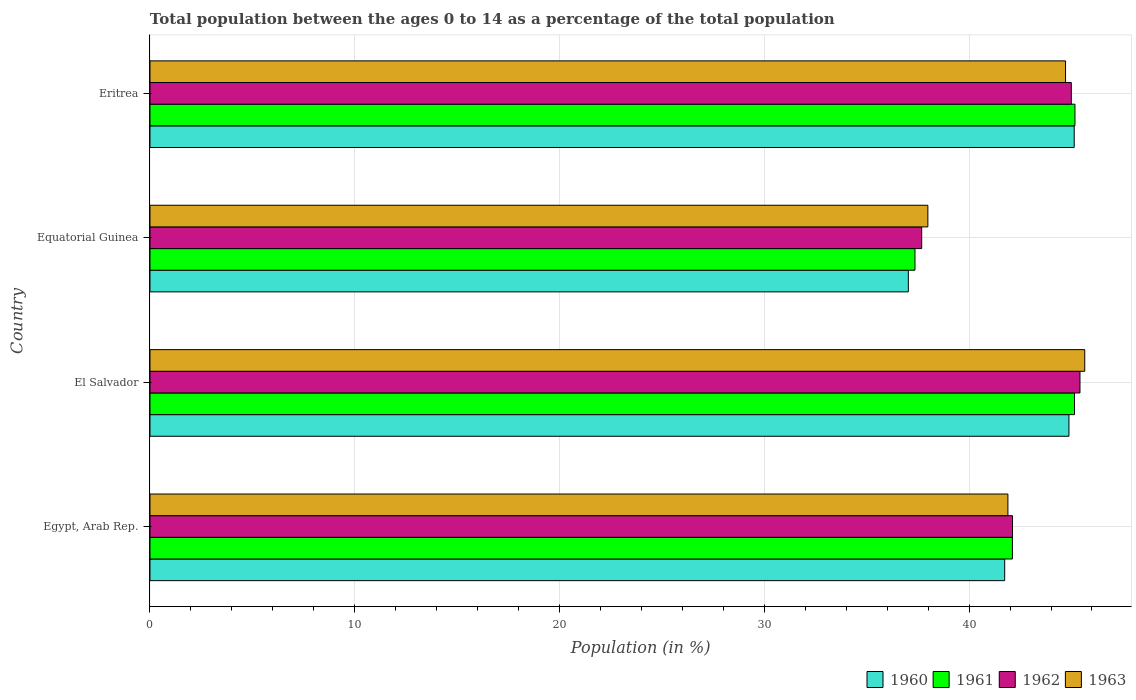Are the number of bars per tick equal to the number of legend labels?
Your response must be concise. Yes. Are the number of bars on each tick of the Y-axis equal?
Offer a terse response. Yes. What is the label of the 3rd group of bars from the top?
Your answer should be compact. El Salvador. What is the percentage of the population ages 0 to 14 in 1961 in Eritrea?
Give a very brief answer. 45.17. Across all countries, what is the maximum percentage of the population ages 0 to 14 in 1962?
Your answer should be very brief. 45.41. Across all countries, what is the minimum percentage of the population ages 0 to 14 in 1963?
Offer a terse response. 37.98. In which country was the percentage of the population ages 0 to 14 in 1961 maximum?
Your response must be concise. Eritrea. In which country was the percentage of the population ages 0 to 14 in 1963 minimum?
Provide a short and direct response. Equatorial Guinea. What is the total percentage of the population ages 0 to 14 in 1961 in the graph?
Your answer should be very brief. 169.78. What is the difference between the percentage of the population ages 0 to 14 in 1962 in Egypt, Arab Rep. and that in El Salvador?
Your answer should be compact. -3.29. What is the difference between the percentage of the population ages 0 to 14 in 1960 in Eritrea and the percentage of the population ages 0 to 14 in 1961 in El Salvador?
Your answer should be compact. -0.02. What is the average percentage of the population ages 0 to 14 in 1963 per country?
Ensure brevity in your answer.  42.56. What is the difference between the percentage of the population ages 0 to 14 in 1961 and percentage of the population ages 0 to 14 in 1962 in El Salvador?
Keep it short and to the point. -0.27. What is the ratio of the percentage of the population ages 0 to 14 in 1961 in Egypt, Arab Rep. to that in El Salvador?
Make the answer very short. 0.93. Is the percentage of the population ages 0 to 14 in 1960 in Equatorial Guinea less than that in Eritrea?
Give a very brief answer. Yes. Is the difference between the percentage of the population ages 0 to 14 in 1961 in Egypt, Arab Rep. and Eritrea greater than the difference between the percentage of the population ages 0 to 14 in 1962 in Egypt, Arab Rep. and Eritrea?
Offer a terse response. No. What is the difference between the highest and the second highest percentage of the population ages 0 to 14 in 1961?
Make the answer very short. 0.02. What is the difference between the highest and the lowest percentage of the population ages 0 to 14 in 1960?
Your answer should be compact. 8.1. In how many countries, is the percentage of the population ages 0 to 14 in 1963 greater than the average percentage of the population ages 0 to 14 in 1963 taken over all countries?
Provide a succinct answer. 2. What does the 4th bar from the bottom in Equatorial Guinea represents?
Offer a terse response. 1963. How many countries are there in the graph?
Your answer should be compact. 4. Where does the legend appear in the graph?
Make the answer very short. Bottom right. How many legend labels are there?
Your answer should be very brief. 4. What is the title of the graph?
Offer a very short reply. Total population between the ages 0 to 14 as a percentage of the total population. What is the Population (in %) of 1960 in Egypt, Arab Rep.?
Your response must be concise. 41.74. What is the Population (in %) of 1961 in Egypt, Arab Rep.?
Your answer should be very brief. 42.11. What is the Population (in %) in 1962 in Egypt, Arab Rep.?
Offer a terse response. 42.12. What is the Population (in %) in 1963 in Egypt, Arab Rep.?
Your response must be concise. 41.89. What is the Population (in %) of 1960 in El Salvador?
Your answer should be very brief. 44.87. What is the Population (in %) in 1961 in El Salvador?
Ensure brevity in your answer.  45.15. What is the Population (in %) of 1962 in El Salvador?
Make the answer very short. 45.41. What is the Population (in %) in 1963 in El Salvador?
Provide a short and direct response. 45.65. What is the Population (in %) in 1960 in Equatorial Guinea?
Your answer should be very brief. 37.03. What is the Population (in %) of 1961 in Equatorial Guinea?
Offer a very short reply. 37.36. What is the Population (in %) of 1962 in Equatorial Guinea?
Offer a terse response. 37.68. What is the Population (in %) of 1963 in Equatorial Guinea?
Offer a very short reply. 37.98. What is the Population (in %) in 1960 in Eritrea?
Provide a short and direct response. 45.13. What is the Population (in %) in 1961 in Eritrea?
Your response must be concise. 45.17. What is the Population (in %) of 1962 in Eritrea?
Ensure brevity in your answer.  44.99. What is the Population (in %) of 1963 in Eritrea?
Give a very brief answer. 44.71. Across all countries, what is the maximum Population (in %) of 1960?
Offer a terse response. 45.13. Across all countries, what is the maximum Population (in %) of 1961?
Ensure brevity in your answer.  45.17. Across all countries, what is the maximum Population (in %) of 1962?
Provide a short and direct response. 45.41. Across all countries, what is the maximum Population (in %) of 1963?
Ensure brevity in your answer.  45.65. Across all countries, what is the minimum Population (in %) in 1960?
Give a very brief answer. 37.03. Across all countries, what is the minimum Population (in %) of 1961?
Keep it short and to the point. 37.36. Across all countries, what is the minimum Population (in %) in 1962?
Offer a terse response. 37.68. Across all countries, what is the minimum Population (in %) of 1963?
Make the answer very short. 37.98. What is the total Population (in %) of 1960 in the graph?
Your answer should be very brief. 168.78. What is the total Population (in %) of 1961 in the graph?
Keep it short and to the point. 169.78. What is the total Population (in %) of 1962 in the graph?
Keep it short and to the point. 170.21. What is the total Population (in %) in 1963 in the graph?
Offer a very short reply. 170.23. What is the difference between the Population (in %) of 1960 in Egypt, Arab Rep. and that in El Salvador?
Your response must be concise. -3.14. What is the difference between the Population (in %) in 1961 in Egypt, Arab Rep. and that in El Salvador?
Keep it short and to the point. -3.03. What is the difference between the Population (in %) in 1962 in Egypt, Arab Rep. and that in El Salvador?
Offer a very short reply. -3.29. What is the difference between the Population (in %) in 1963 in Egypt, Arab Rep. and that in El Salvador?
Make the answer very short. -3.75. What is the difference between the Population (in %) of 1960 in Egypt, Arab Rep. and that in Equatorial Guinea?
Ensure brevity in your answer.  4.7. What is the difference between the Population (in %) of 1961 in Egypt, Arab Rep. and that in Equatorial Guinea?
Your answer should be compact. 4.76. What is the difference between the Population (in %) of 1962 in Egypt, Arab Rep. and that in Equatorial Guinea?
Your answer should be very brief. 4.43. What is the difference between the Population (in %) of 1963 in Egypt, Arab Rep. and that in Equatorial Guinea?
Give a very brief answer. 3.91. What is the difference between the Population (in %) of 1960 in Egypt, Arab Rep. and that in Eritrea?
Keep it short and to the point. -3.39. What is the difference between the Population (in %) in 1961 in Egypt, Arab Rep. and that in Eritrea?
Provide a succinct answer. -3.05. What is the difference between the Population (in %) of 1962 in Egypt, Arab Rep. and that in Eritrea?
Your response must be concise. -2.87. What is the difference between the Population (in %) in 1963 in Egypt, Arab Rep. and that in Eritrea?
Make the answer very short. -2.81. What is the difference between the Population (in %) of 1960 in El Salvador and that in Equatorial Guinea?
Your answer should be very brief. 7.84. What is the difference between the Population (in %) of 1961 in El Salvador and that in Equatorial Guinea?
Offer a very short reply. 7.79. What is the difference between the Population (in %) of 1962 in El Salvador and that in Equatorial Guinea?
Offer a terse response. 7.73. What is the difference between the Population (in %) of 1963 in El Salvador and that in Equatorial Guinea?
Your answer should be compact. 7.66. What is the difference between the Population (in %) in 1960 in El Salvador and that in Eritrea?
Your answer should be compact. -0.26. What is the difference between the Population (in %) in 1961 in El Salvador and that in Eritrea?
Ensure brevity in your answer.  -0.02. What is the difference between the Population (in %) of 1962 in El Salvador and that in Eritrea?
Your response must be concise. 0.42. What is the difference between the Population (in %) in 1963 in El Salvador and that in Eritrea?
Your response must be concise. 0.94. What is the difference between the Population (in %) in 1960 in Equatorial Guinea and that in Eritrea?
Make the answer very short. -8.1. What is the difference between the Population (in %) of 1961 in Equatorial Guinea and that in Eritrea?
Keep it short and to the point. -7.81. What is the difference between the Population (in %) of 1962 in Equatorial Guinea and that in Eritrea?
Keep it short and to the point. -7.31. What is the difference between the Population (in %) of 1963 in Equatorial Guinea and that in Eritrea?
Make the answer very short. -6.72. What is the difference between the Population (in %) of 1960 in Egypt, Arab Rep. and the Population (in %) of 1961 in El Salvador?
Your answer should be compact. -3.41. What is the difference between the Population (in %) in 1960 in Egypt, Arab Rep. and the Population (in %) in 1962 in El Salvador?
Make the answer very short. -3.68. What is the difference between the Population (in %) in 1960 in Egypt, Arab Rep. and the Population (in %) in 1963 in El Salvador?
Offer a very short reply. -3.91. What is the difference between the Population (in %) in 1961 in Egypt, Arab Rep. and the Population (in %) in 1962 in El Salvador?
Ensure brevity in your answer.  -3.3. What is the difference between the Population (in %) of 1961 in Egypt, Arab Rep. and the Population (in %) of 1963 in El Salvador?
Offer a very short reply. -3.53. What is the difference between the Population (in %) in 1962 in Egypt, Arab Rep. and the Population (in %) in 1963 in El Salvador?
Provide a succinct answer. -3.53. What is the difference between the Population (in %) in 1960 in Egypt, Arab Rep. and the Population (in %) in 1961 in Equatorial Guinea?
Keep it short and to the point. 4.38. What is the difference between the Population (in %) in 1960 in Egypt, Arab Rep. and the Population (in %) in 1962 in Equatorial Guinea?
Provide a succinct answer. 4.05. What is the difference between the Population (in %) in 1960 in Egypt, Arab Rep. and the Population (in %) in 1963 in Equatorial Guinea?
Offer a very short reply. 3.75. What is the difference between the Population (in %) in 1961 in Egypt, Arab Rep. and the Population (in %) in 1962 in Equatorial Guinea?
Ensure brevity in your answer.  4.43. What is the difference between the Population (in %) of 1961 in Egypt, Arab Rep. and the Population (in %) of 1963 in Equatorial Guinea?
Provide a succinct answer. 4.13. What is the difference between the Population (in %) in 1962 in Egypt, Arab Rep. and the Population (in %) in 1963 in Equatorial Guinea?
Make the answer very short. 4.13. What is the difference between the Population (in %) of 1960 in Egypt, Arab Rep. and the Population (in %) of 1961 in Eritrea?
Your answer should be very brief. -3.43. What is the difference between the Population (in %) in 1960 in Egypt, Arab Rep. and the Population (in %) in 1962 in Eritrea?
Your answer should be compact. -3.25. What is the difference between the Population (in %) of 1960 in Egypt, Arab Rep. and the Population (in %) of 1963 in Eritrea?
Your answer should be very brief. -2.97. What is the difference between the Population (in %) of 1961 in Egypt, Arab Rep. and the Population (in %) of 1962 in Eritrea?
Offer a very short reply. -2.88. What is the difference between the Population (in %) in 1961 in Egypt, Arab Rep. and the Population (in %) in 1963 in Eritrea?
Your response must be concise. -2.59. What is the difference between the Population (in %) in 1962 in Egypt, Arab Rep. and the Population (in %) in 1963 in Eritrea?
Keep it short and to the point. -2.59. What is the difference between the Population (in %) in 1960 in El Salvador and the Population (in %) in 1961 in Equatorial Guinea?
Give a very brief answer. 7.52. What is the difference between the Population (in %) of 1960 in El Salvador and the Population (in %) of 1962 in Equatorial Guinea?
Provide a short and direct response. 7.19. What is the difference between the Population (in %) of 1960 in El Salvador and the Population (in %) of 1963 in Equatorial Guinea?
Keep it short and to the point. 6.89. What is the difference between the Population (in %) in 1961 in El Salvador and the Population (in %) in 1962 in Equatorial Guinea?
Your answer should be compact. 7.46. What is the difference between the Population (in %) of 1961 in El Salvador and the Population (in %) of 1963 in Equatorial Guinea?
Offer a very short reply. 7.16. What is the difference between the Population (in %) of 1962 in El Salvador and the Population (in %) of 1963 in Equatorial Guinea?
Your answer should be very brief. 7.43. What is the difference between the Population (in %) in 1960 in El Salvador and the Population (in %) in 1961 in Eritrea?
Provide a short and direct response. -0.29. What is the difference between the Population (in %) in 1960 in El Salvador and the Population (in %) in 1962 in Eritrea?
Offer a terse response. -0.12. What is the difference between the Population (in %) of 1960 in El Salvador and the Population (in %) of 1963 in Eritrea?
Make the answer very short. 0.17. What is the difference between the Population (in %) of 1961 in El Salvador and the Population (in %) of 1962 in Eritrea?
Give a very brief answer. 0.16. What is the difference between the Population (in %) of 1961 in El Salvador and the Population (in %) of 1963 in Eritrea?
Your response must be concise. 0.44. What is the difference between the Population (in %) of 1962 in El Salvador and the Population (in %) of 1963 in Eritrea?
Your answer should be very brief. 0.71. What is the difference between the Population (in %) of 1960 in Equatorial Guinea and the Population (in %) of 1961 in Eritrea?
Ensure brevity in your answer.  -8.14. What is the difference between the Population (in %) of 1960 in Equatorial Guinea and the Population (in %) of 1962 in Eritrea?
Your response must be concise. -7.96. What is the difference between the Population (in %) of 1960 in Equatorial Guinea and the Population (in %) of 1963 in Eritrea?
Ensure brevity in your answer.  -7.68. What is the difference between the Population (in %) of 1961 in Equatorial Guinea and the Population (in %) of 1962 in Eritrea?
Make the answer very short. -7.64. What is the difference between the Population (in %) of 1961 in Equatorial Guinea and the Population (in %) of 1963 in Eritrea?
Offer a terse response. -7.35. What is the difference between the Population (in %) of 1962 in Equatorial Guinea and the Population (in %) of 1963 in Eritrea?
Provide a short and direct response. -7.02. What is the average Population (in %) in 1960 per country?
Make the answer very short. 42.19. What is the average Population (in %) in 1961 per country?
Keep it short and to the point. 42.45. What is the average Population (in %) in 1962 per country?
Provide a succinct answer. 42.55. What is the average Population (in %) of 1963 per country?
Offer a terse response. 42.56. What is the difference between the Population (in %) in 1960 and Population (in %) in 1961 in Egypt, Arab Rep.?
Ensure brevity in your answer.  -0.38. What is the difference between the Population (in %) of 1960 and Population (in %) of 1962 in Egypt, Arab Rep.?
Your answer should be very brief. -0.38. What is the difference between the Population (in %) in 1960 and Population (in %) in 1963 in Egypt, Arab Rep.?
Make the answer very short. -0.16. What is the difference between the Population (in %) in 1961 and Population (in %) in 1962 in Egypt, Arab Rep.?
Offer a terse response. -0.01. What is the difference between the Population (in %) in 1961 and Population (in %) in 1963 in Egypt, Arab Rep.?
Offer a very short reply. 0.22. What is the difference between the Population (in %) of 1962 and Population (in %) of 1963 in Egypt, Arab Rep.?
Provide a succinct answer. 0.22. What is the difference between the Population (in %) of 1960 and Population (in %) of 1961 in El Salvador?
Provide a succinct answer. -0.27. What is the difference between the Population (in %) in 1960 and Population (in %) in 1962 in El Salvador?
Your answer should be very brief. -0.54. What is the difference between the Population (in %) of 1960 and Population (in %) of 1963 in El Salvador?
Ensure brevity in your answer.  -0.77. What is the difference between the Population (in %) of 1961 and Population (in %) of 1962 in El Salvador?
Give a very brief answer. -0.27. What is the difference between the Population (in %) of 1961 and Population (in %) of 1963 in El Salvador?
Provide a succinct answer. -0.5. What is the difference between the Population (in %) in 1962 and Population (in %) in 1963 in El Salvador?
Ensure brevity in your answer.  -0.23. What is the difference between the Population (in %) in 1960 and Population (in %) in 1961 in Equatorial Guinea?
Give a very brief answer. -0.32. What is the difference between the Population (in %) of 1960 and Population (in %) of 1962 in Equatorial Guinea?
Offer a very short reply. -0.65. What is the difference between the Population (in %) of 1960 and Population (in %) of 1963 in Equatorial Guinea?
Offer a very short reply. -0.95. What is the difference between the Population (in %) in 1961 and Population (in %) in 1962 in Equatorial Guinea?
Give a very brief answer. -0.33. What is the difference between the Population (in %) of 1961 and Population (in %) of 1963 in Equatorial Guinea?
Give a very brief answer. -0.63. What is the difference between the Population (in %) in 1962 and Population (in %) in 1963 in Equatorial Guinea?
Ensure brevity in your answer.  -0.3. What is the difference between the Population (in %) of 1960 and Population (in %) of 1961 in Eritrea?
Provide a succinct answer. -0.04. What is the difference between the Population (in %) in 1960 and Population (in %) in 1962 in Eritrea?
Offer a terse response. 0.14. What is the difference between the Population (in %) in 1960 and Population (in %) in 1963 in Eritrea?
Your answer should be very brief. 0.42. What is the difference between the Population (in %) in 1961 and Population (in %) in 1962 in Eritrea?
Your answer should be very brief. 0.18. What is the difference between the Population (in %) in 1961 and Population (in %) in 1963 in Eritrea?
Your answer should be very brief. 0.46. What is the difference between the Population (in %) of 1962 and Population (in %) of 1963 in Eritrea?
Keep it short and to the point. 0.28. What is the ratio of the Population (in %) in 1960 in Egypt, Arab Rep. to that in El Salvador?
Your answer should be compact. 0.93. What is the ratio of the Population (in %) in 1961 in Egypt, Arab Rep. to that in El Salvador?
Provide a short and direct response. 0.93. What is the ratio of the Population (in %) in 1962 in Egypt, Arab Rep. to that in El Salvador?
Your answer should be very brief. 0.93. What is the ratio of the Population (in %) in 1963 in Egypt, Arab Rep. to that in El Salvador?
Make the answer very short. 0.92. What is the ratio of the Population (in %) of 1960 in Egypt, Arab Rep. to that in Equatorial Guinea?
Your response must be concise. 1.13. What is the ratio of the Population (in %) of 1961 in Egypt, Arab Rep. to that in Equatorial Guinea?
Make the answer very short. 1.13. What is the ratio of the Population (in %) in 1962 in Egypt, Arab Rep. to that in Equatorial Guinea?
Ensure brevity in your answer.  1.12. What is the ratio of the Population (in %) in 1963 in Egypt, Arab Rep. to that in Equatorial Guinea?
Offer a very short reply. 1.1. What is the ratio of the Population (in %) of 1960 in Egypt, Arab Rep. to that in Eritrea?
Give a very brief answer. 0.92. What is the ratio of the Population (in %) of 1961 in Egypt, Arab Rep. to that in Eritrea?
Keep it short and to the point. 0.93. What is the ratio of the Population (in %) of 1962 in Egypt, Arab Rep. to that in Eritrea?
Make the answer very short. 0.94. What is the ratio of the Population (in %) in 1963 in Egypt, Arab Rep. to that in Eritrea?
Give a very brief answer. 0.94. What is the ratio of the Population (in %) of 1960 in El Salvador to that in Equatorial Guinea?
Provide a succinct answer. 1.21. What is the ratio of the Population (in %) of 1961 in El Salvador to that in Equatorial Guinea?
Provide a short and direct response. 1.21. What is the ratio of the Population (in %) of 1962 in El Salvador to that in Equatorial Guinea?
Your answer should be very brief. 1.21. What is the ratio of the Population (in %) of 1963 in El Salvador to that in Equatorial Guinea?
Offer a terse response. 1.2. What is the ratio of the Population (in %) in 1960 in El Salvador to that in Eritrea?
Offer a very short reply. 0.99. What is the ratio of the Population (in %) of 1961 in El Salvador to that in Eritrea?
Offer a very short reply. 1. What is the ratio of the Population (in %) in 1962 in El Salvador to that in Eritrea?
Keep it short and to the point. 1.01. What is the ratio of the Population (in %) of 1963 in El Salvador to that in Eritrea?
Your answer should be very brief. 1.02. What is the ratio of the Population (in %) of 1960 in Equatorial Guinea to that in Eritrea?
Give a very brief answer. 0.82. What is the ratio of the Population (in %) in 1961 in Equatorial Guinea to that in Eritrea?
Keep it short and to the point. 0.83. What is the ratio of the Population (in %) of 1962 in Equatorial Guinea to that in Eritrea?
Keep it short and to the point. 0.84. What is the ratio of the Population (in %) in 1963 in Equatorial Guinea to that in Eritrea?
Your response must be concise. 0.85. What is the difference between the highest and the second highest Population (in %) in 1960?
Your answer should be very brief. 0.26. What is the difference between the highest and the second highest Population (in %) of 1961?
Keep it short and to the point. 0.02. What is the difference between the highest and the second highest Population (in %) in 1962?
Provide a short and direct response. 0.42. What is the difference between the highest and the second highest Population (in %) in 1963?
Make the answer very short. 0.94. What is the difference between the highest and the lowest Population (in %) in 1960?
Your answer should be very brief. 8.1. What is the difference between the highest and the lowest Population (in %) of 1961?
Your answer should be compact. 7.81. What is the difference between the highest and the lowest Population (in %) of 1962?
Your answer should be very brief. 7.73. What is the difference between the highest and the lowest Population (in %) in 1963?
Offer a very short reply. 7.66. 